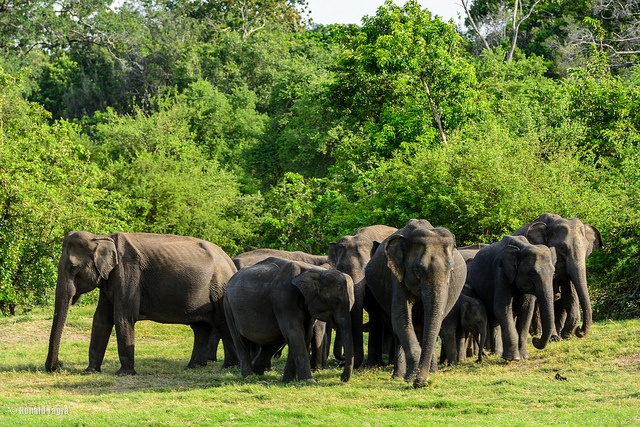Describe the objects in this image and their specific colors. I can see elephant in olive, black, tan, gray, and darkgreen tones, elephant in olive, black, gray, and darkgray tones, elephant in olive, black, tan, and gray tones, elephant in olive, black, gray, and tan tones, and elephant in olive, black, tan, gray, and darkgreen tones in this image. 